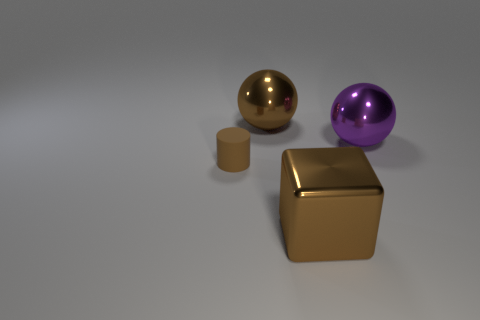Add 2 big red blocks. How many objects exist? 6 Subtract all cylinders. How many objects are left? 3 Subtract 0 yellow cylinders. How many objects are left? 4 Subtract all large gray blocks. Subtract all matte cylinders. How many objects are left? 3 Add 4 rubber cylinders. How many rubber cylinders are left? 5 Add 4 tiny purple matte spheres. How many tiny purple matte spheres exist? 4 